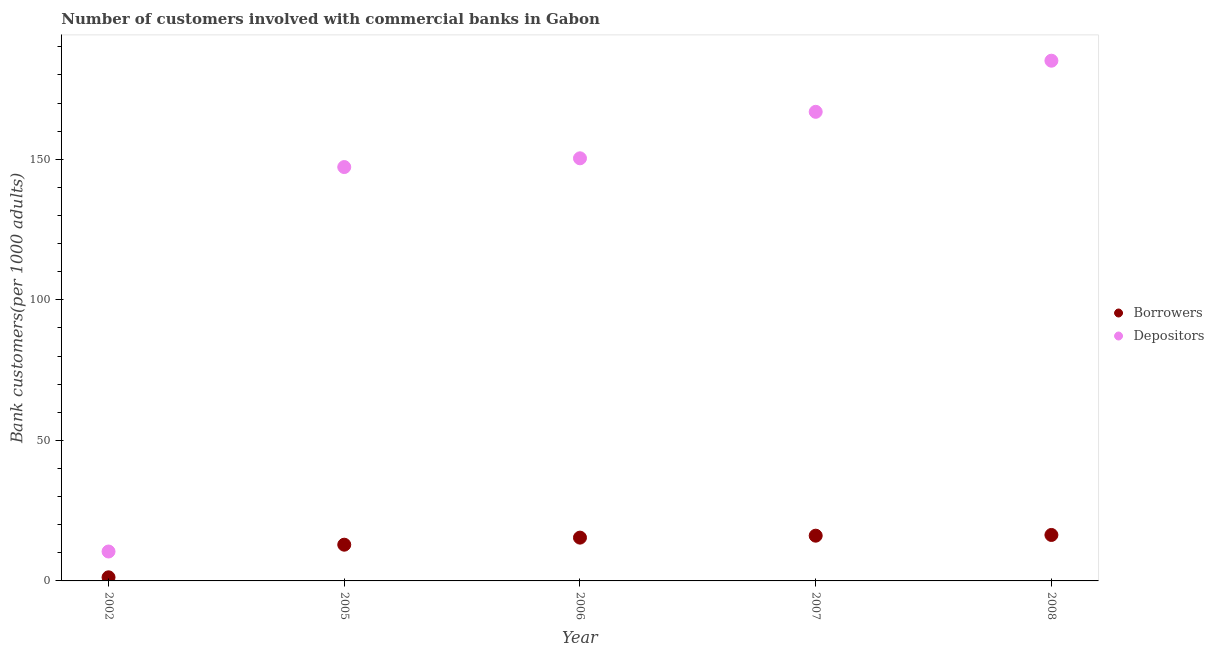How many different coloured dotlines are there?
Your answer should be compact. 2. Is the number of dotlines equal to the number of legend labels?
Keep it short and to the point. Yes. What is the number of borrowers in 2005?
Your answer should be very brief. 12.89. Across all years, what is the maximum number of borrowers?
Your response must be concise. 16.35. Across all years, what is the minimum number of borrowers?
Your response must be concise. 1.28. What is the total number of borrowers in the graph?
Your answer should be very brief. 62.02. What is the difference between the number of borrowers in 2006 and that in 2008?
Your response must be concise. -0.95. What is the difference between the number of borrowers in 2002 and the number of depositors in 2005?
Keep it short and to the point. -145.94. What is the average number of depositors per year?
Give a very brief answer. 131.99. In the year 2006, what is the difference between the number of depositors and number of borrowers?
Your answer should be compact. 134.94. What is the ratio of the number of borrowers in 2002 to that in 2006?
Ensure brevity in your answer.  0.08. Is the number of borrowers in 2006 less than that in 2007?
Your response must be concise. Yes. Is the difference between the number of borrowers in 2002 and 2005 greater than the difference between the number of depositors in 2002 and 2005?
Keep it short and to the point. Yes. What is the difference between the highest and the second highest number of depositors?
Ensure brevity in your answer.  18.18. What is the difference between the highest and the lowest number of depositors?
Offer a terse response. 174.6. In how many years, is the number of borrowers greater than the average number of borrowers taken over all years?
Make the answer very short. 4. Is the sum of the number of borrowers in 2002 and 2008 greater than the maximum number of depositors across all years?
Ensure brevity in your answer.  No. Does the number of borrowers monotonically increase over the years?
Keep it short and to the point. Yes. Is the number of borrowers strictly greater than the number of depositors over the years?
Give a very brief answer. No. What is the difference between two consecutive major ticks on the Y-axis?
Keep it short and to the point. 50. Does the graph contain any zero values?
Offer a very short reply. No. Does the graph contain grids?
Keep it short and to the point. No. Where does the legend appear in the graph?
Keep it short and to the point. Center right. What is the title of the graph?
Provide a short and direct response. Number of customers involved with commercial banks in Gabon. What is the label or title of the Y-axis?
Your answer should be very brief. Bank customers(per 1000 adults). What is the Bank customers(per 1000 adults) of Borrowers in 2002?
Make the answer very short. 1.28. What is the Bank customers(per 1000 adults) of Depositors in 2002?
Give a very brief answer. 10.46. What is the Bank customers(per 1000 adults) of Borrowers in 2005?
Your response must be concise. 12.89. What is the Bank customers(per 1000 adults) of Depositors in 2005?
Provide a succinct answer. 147.22. What is the Bank customers(per 1000 adults) in Borrowers in 2006?
Provide a succinct answer. 15.4. What is the Bank customers(per 1000 adults) in Depositors in 2006?
Provide a succinct answer. 150.34. What is the Bank customers(per 1000 adults) in Borrowers in 2007?
Give a very brief answer. 16.09. What is the Bank customers(per 1000 adults) in Depositors in 2007?
Keep it short and to the point. 166.87. What is the Bank customers(per 1000 adults) in Borrowers in 2008?
Keep it short and to the point. 16.35. What is the Bank customers(per 1000 adults) of Depositors in 2008?
Your answer should be compact. 185.06. Across all years, what is the maximum Bank customers(per 1000 adults) of Borrowers?
Your answer should be compact. 16.35. Across all years, what is the maximum Bank customers(per 1000 adults) in Depositors?
Ensure brevity in your answer.  185.06. Across all years, what is the minimum Bank customers(per 1000 adults) of Borrowers?
Give a very brief answer. 1.28. Across all years, what is the minimum Bank customers(per 1000 adults) in Depositors?
Keep it short and to the point. 10.46. What is the total Bank customers(per 1000 adults) of Borrowers in the graph?
Keep it short and to the point. 62.02. What is the total Bank customers(per 1000 adults) of Depositors in the graph?
Keep it short and to the point. 659.95. What is the difference between the Bank customers(per 1000 adults) of Borrowers in 2002 and that in 2005?
Give a very brief answer. -11.61. What is the difference between the Bank customers(per 1000 adults) of Depositors in 2002 and that in 2005?
Your response must be concise. -136.76. What is the difference between the Bank customers(per 1000 adults) in Borrowers in 2002 and that in 2006?
Give a very brief answer. -14.12. What is the difference between the Bank customers(per 1000 adults) in Depositors in 2002 and that in 2006?
Offer a very short reply. -139.88. What is the difference between the Bank customers(per 1000 adults) of Borrowers in 2002 and that in 2007?
Offer a very short reply. -14.81. What is the difference between the Bank customers(per 1000 adults) of Depositors in 2002 and that in 2007?
Ensure brevity in your answer.  -156.41. What is the difference between the Bank customers(per 1000 adults) in Borrowers in 2002 and that in 2008?
Offer a very short reply. -15.07. What is the difference between the Bank customers(per 1000 adults) in Depositors in 2002 and that in 2008?
Your answer should be very brief. -174.6. What is the difference between the Bank customers(per 1000 adults) in Borrowers in 2005 and that in 2006?
Ensure brevity in your answer.  -2.51. What is the difference between the Bank customers(per 1000 adults) in Depositors in 2005 and that in 2006?
Provide a succinct answer. -3.11. What is the difference between the Bank customers(per 1000 adults) of Borrowers in 2005 and that in 2007?
Offer a very short reply. -3.2. What is the difference between the Bank customers(per 1000 adults) in Depositors in 2005 and that in 2007?
Keep it short and to the point. -19.65. What is the difference between the Bank customers(per 1000 adults) in Borrowers in 2005 and that in 2008?
Your response must be concise. -3.46. What is the difference between the Bank customers(per 1000 adults) in Depositors in 2005 and that in 2008?
Your response must be concise. -37.83. What is the difference between the Bank customers(per 1000 adults) of Borrowers in 2006 and that in 2007?
Provide a short and direct response. -0.69. What is the difference between the Bank customers(per 1000 adults) of Depositors in 2006 and that in 2007?
Offer a terse response. -16.54. What is the difference between the Bank customers(per 1000 adults) of Borrowers in 2006 and that in 2008?
Provide a succinct answer. -0.95. What is the difference between the Bank customers(per 1000 adults) in Depositors in 2006 and that in 2008?
Your answer should be compact. -34.72. What is the difference between the Bank customers(per 1000 adults) in Borrowers in 2007 and that in 2008?
Your response must be concise. -0.26. What is the difference between the Bank customers(per 1000 adults) in Depositors in 2007 and that in 2008?
Ensure brevity in your answer.  -18.18. What is the difference between the Bank customers(per 1000 adults) of Borrowers in 2002 and the Bank customers(per 1000 adults) of Depositors in 2005?
Provide a short and direct response. -145.94. What is the difference between the Bank customers(per 1000 adults) of Borrowers in 2002 and the Bank customers(per 1000 adults) of Depositors in 2006?
Your response must be concise. -149.06. What is the difference between the Bank customers(per 1000 adults) of Borrowers in 2002 and the Bank customers(per 1000 adults) of Depositors in 2007?
Make the answer very short. -165.59. What is the difference between the Bank customers(per 1000 adults) in Borrowers in 2002 and the Bank customers(per 1000 adults) in Depositors in 2008?
Offer a very short reply. -183.77. What is the difference between the Bank customers(per 1000 adults) of Borrowers in 2005 and the Bank customers(per 1000 adults) of Depositors in 2006?
Offer a very short reply. -137.45. What is the difference between the Bank customers(per 1000 adults) in Borrowers in 2005 and the Bank customers(per 1000 adults) in Depositors in 2007?
Offer a very short reply. -153.99. What is the difference between the Bank customers(per 1000 adults) of Borrowers in 2005 and the Bank customers(per 1000 adults) of Depositors in 2008?
Make the answer very short. -172.17. What is the difference between the Bank customers(per 1000 adults) of Borrowers in 2006 and the Bank customers(per 1000 adults) of Depositors in 2007?
Offer a very short reply. -151.47. What is the difference between the Bank customers(per 1000 adults) in Borrowers in 2006 and the Bank customers(per 1000 adults) in Depositors in 2008?
Ensure brevity in your answer.  -169.66. What is the difference between the Bank customers(per 1000 adults) of Borrowers in 2007 and the Bank customers(per 1000 adults) of Depositors in 2008?
Your answer should be very brief. -168.97. What is the average Bank customers(per 1000 adults) of Borrowers per year?
Offer a very short reply. 12.4. What is the average Bank customers(per 1000 adults) of Depositors per year?
Offer a terse response. 131.99. In the year 2002, what is the difference between the Bank customers(per 1000 adults) in Borrowers and Bank customers(per 1000 adults) in Depositors?
Your answer should be compact. -9.18. In the year 2005, what is the difference between the Bank customers(per 1000 adults) of Borrowers and Bank customers(per 1000 adults) of Depositors?
Offer a very short reply. -134.33. In the year 2006, what is the difference between the Bank customers(per 1000 adults) in Borrowers and Bank customers(per 1000 adults) in Depositors?
Your answer should be compact. -134.94. In the year 2007, what is the difference between the Bank customers(per 1000 adults) in Borrowers and Bank customers(per 1000 adults) in Depositors?
Offer a terse response. -150.78. In the year 2008, what is the difference between the Bank customers(per 1000 adults) in Borrowers and Bank customers(per 1000 adults) in Depositors?
Keep it short and to the point. -168.71. What is the ratio of the Bank customers(per 1000 adults) of Borrowers in 2002 to that in 2005?
Make the answer very short. 0.1. What is the ratio of the Bank customers(per 1000 adults) of Depositors in 2002 to that in 2005?
Offer a very short reply. 0.07. What is the ratio of the Bank customers(per 1000 adults) in Borrowers in 2002 to that in 2006?
Keep it short and to the point. 0.08. What is the ratio of the Bank customers(per 1000 adults) of Depositors in 2002 to that in 2006?
Provide a short and direct response. 0.07. What is the ratio of the Bank customers(per 1000 adults) of Borrowers in 2002 to that in 2007?
Your response must be concise. 0.08. What is the ratio of the Bank customers(per 1000 adults) in Depositors in 2002 to that in 2007?
Give a very brief answer. 0.06. What is the ratio of the Bank customers(per 1000 adults) in Borrowers in 2002 to that in 2008?
Offer a very short reply. 0.08. What is the ratio of the Bank customers(per 1000 adults) in Depositors in 2002 to that in 2008?
Your response must be concise. 0.06. What is the ratio of the Bank customers(per 1000 adults) in Borrowers in 2005 to that in 2006?
Offer a very short reply. 0.84. What is the ratio of the Bank customers(per 1000 adults) in Depositors in 2005 to that in 2006?
Offer a terse response. 0.98. What is the ratio of the Bank customers(per 1000 adults) in Borrowers in 2005 to that in 2007?
Provide a short and direct response. 0.8. What is the ratio of the Bank customers(per 1000 adults) of Depositors in 2005 to that in 2007?
Make the answer very short. 0.88. What is the ratio of the Bank customers(per 1000 adults) in Borrowers in 2005 to that in 2008?
Provide a succinct answer. 0.79. What is the ratio of the Bank customers(per 1000 adults) in Depositors in 2005 to that in 2008?
Ensure brevity in your answer.  0.8. What is the ratio of the Bank customers(per 1000 adults) in Borrowers in 2006 to that in 2007?
Give a very brief answer. 0.96. What is the ratio of the Bank customers(per 1000 adults) of Depositors in 2006 to that in 2007?
Provide a short and direct response. 0.9. What is the ratio of the Bank customers(per 1000 adults) of Borrowers in 2006 to that in 2008?
Keep it short and to the point. 0.94. What is the ratio of the Bank customers(per 1000 adults) in Depositors in 2006 to that in 2008?
Give a very brief answer. 0.81. What is the ratio of the Bank customers(per 1000 adults) in Borrowers in 2007 to that in 2008?
Your answer should be compact. 0.98. What is the ratio of the Bank customers(per 1000 adults) of Depositors in 2007 to that in 2008?
Offer a very short reply. 0.9. What is the difference between the highest and the second highest Bank customers(per 1000 adults) of Borrowers?
Ensure brevity in your answer.  0.26. What is the difference between the highest and the second highest Bank customers(per 1000 adults) of Depositors?
Your answer should be very brief. 18.18. What is the difference between the highest and the lowest Bank customers(per 1000 adults) in Borrowers?
Give a very brief answer. 15.07. What is the difference between the highest and the lowest Bank customers(per 1000 adults) of Depositors?
Your answer should be very brief. 174.6. 